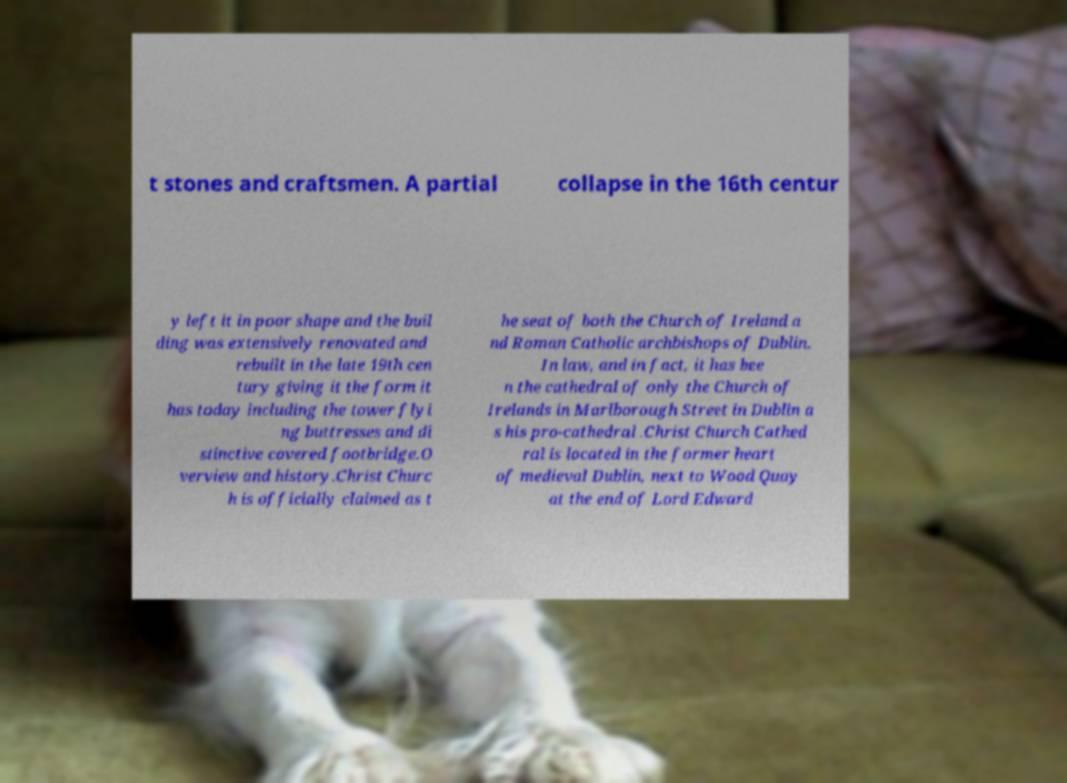Can you accurately transcribe the text from the provided image for me? t stones and craftsmen. A partial collapse in the 16th centur y left it in poor shape and the buil ding was extensively renovated and rebuilt in the late 19th cen tury giving it the form it has today including the tower flyi ng buttresses and di stinctive covered footbridge.O verview and history.Christ Churc h is officially claimed as t he seat of both the Church of Ireland a nd Roman Catholic archbishops of Dublin. In law, and in fact, it has bee n the cathedral of only the Church of Irelands in Marlborough Street in Dublin a s his pro-cathedral .Christ Church Cathed ral is located in the former heart of medieval Dublin, next to Wood Quay at the end of Lord Edward 